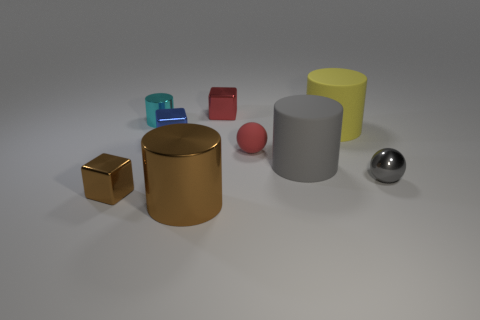Subtract all cyan cylinders. How many cylinders are left? 3 Add 1 small brown cubes. How many objects exist? 10 Subtract 2 cylinders. How many cylinders are left? 2 Subtract all brown cylinders. How many cylinders are left? 3 Subtract all cylinders. How many objects are left? 5 Subtract all yellow cubes. Subtract all purple cylinders. How many cubes are left? 3 Add 2 tiny cylinders. How many tiny cylinders are left? 3 Add 6 small cyan shiny cylinders. How many small cyan shiny cylinders exist? 7 Subtract 1 gray balls. How many objects are left? 8 Subtract all gray rubber things. Subtract all large yellow matte objects. How many objects are left? 7 